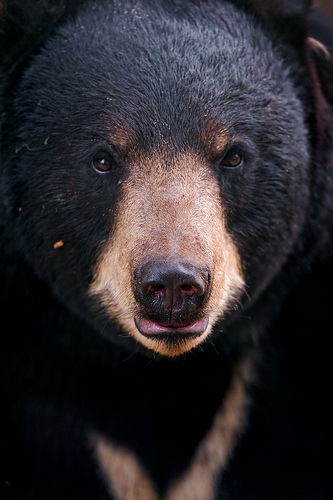What details can you observe about the bear's fur? The bear’s fur varies in color and texture. The majority of the fur is dark brown or black, providing a rich contrast to the lighter tan areas on its muzzle and around the eyes. The fur appears thick and somewhat coarse, suggesting it plays a substantial role in insulating the bear from cold environments. Given the texture of the bear's fur, how might it feel to touch? Based on the appearance, the bear’s fur might feel somewhat rough and dense to the touch. The darker areas might feel more bristly and coarse, while the lighter areas, especially around the muzzle and eye region, might feel softer due to being shorter and less dense. 